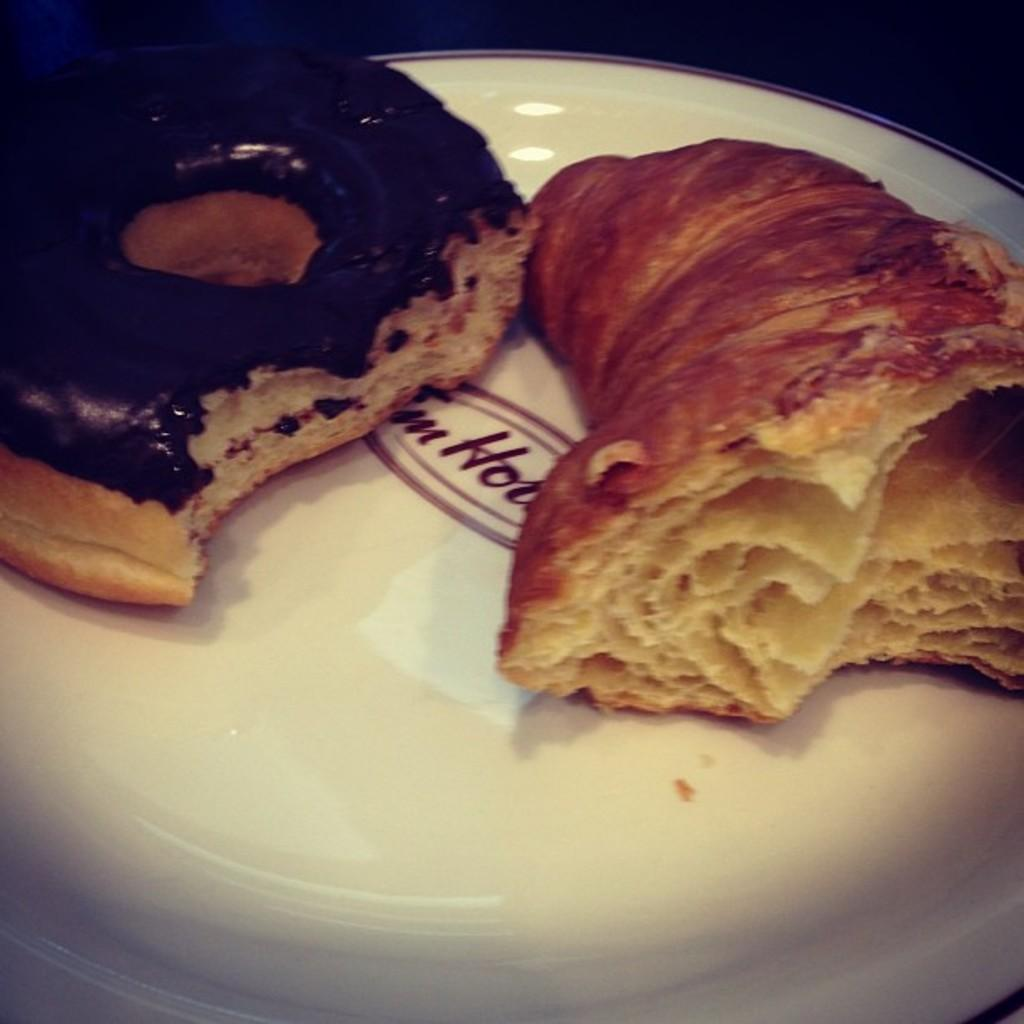What type of food is present in the image? There are two confectionery items in the image. How are the confectionery items arranged in the image? The confectionery items are served on a plate. Reasoning: Let's think step by step by step in order to produce the conversation. We start by identifying the main subject in the image, which is the confectionery items. Then, we expand the conversation to include the arrangement of the items on a plate. Each question is designed to elicit a specific detail about the image that is known from the provided facts. Absurd Question/Answer: How many trains are visible in the image? There are no trains present in the image; it features two confectionery items served on a plate. What type of quilt is used to cover the confectionery items in the image? There is no quilt present in the image; the confectionery items are served on a plate without any covering. How many trains are visible in the image? There are no trains present in the image; it features two confectionery items served on a plate. What type of quilt is used to cover the confectionery items in the image? There is no quilt present in the image; the confectionery items are served on a plate without any covering. 